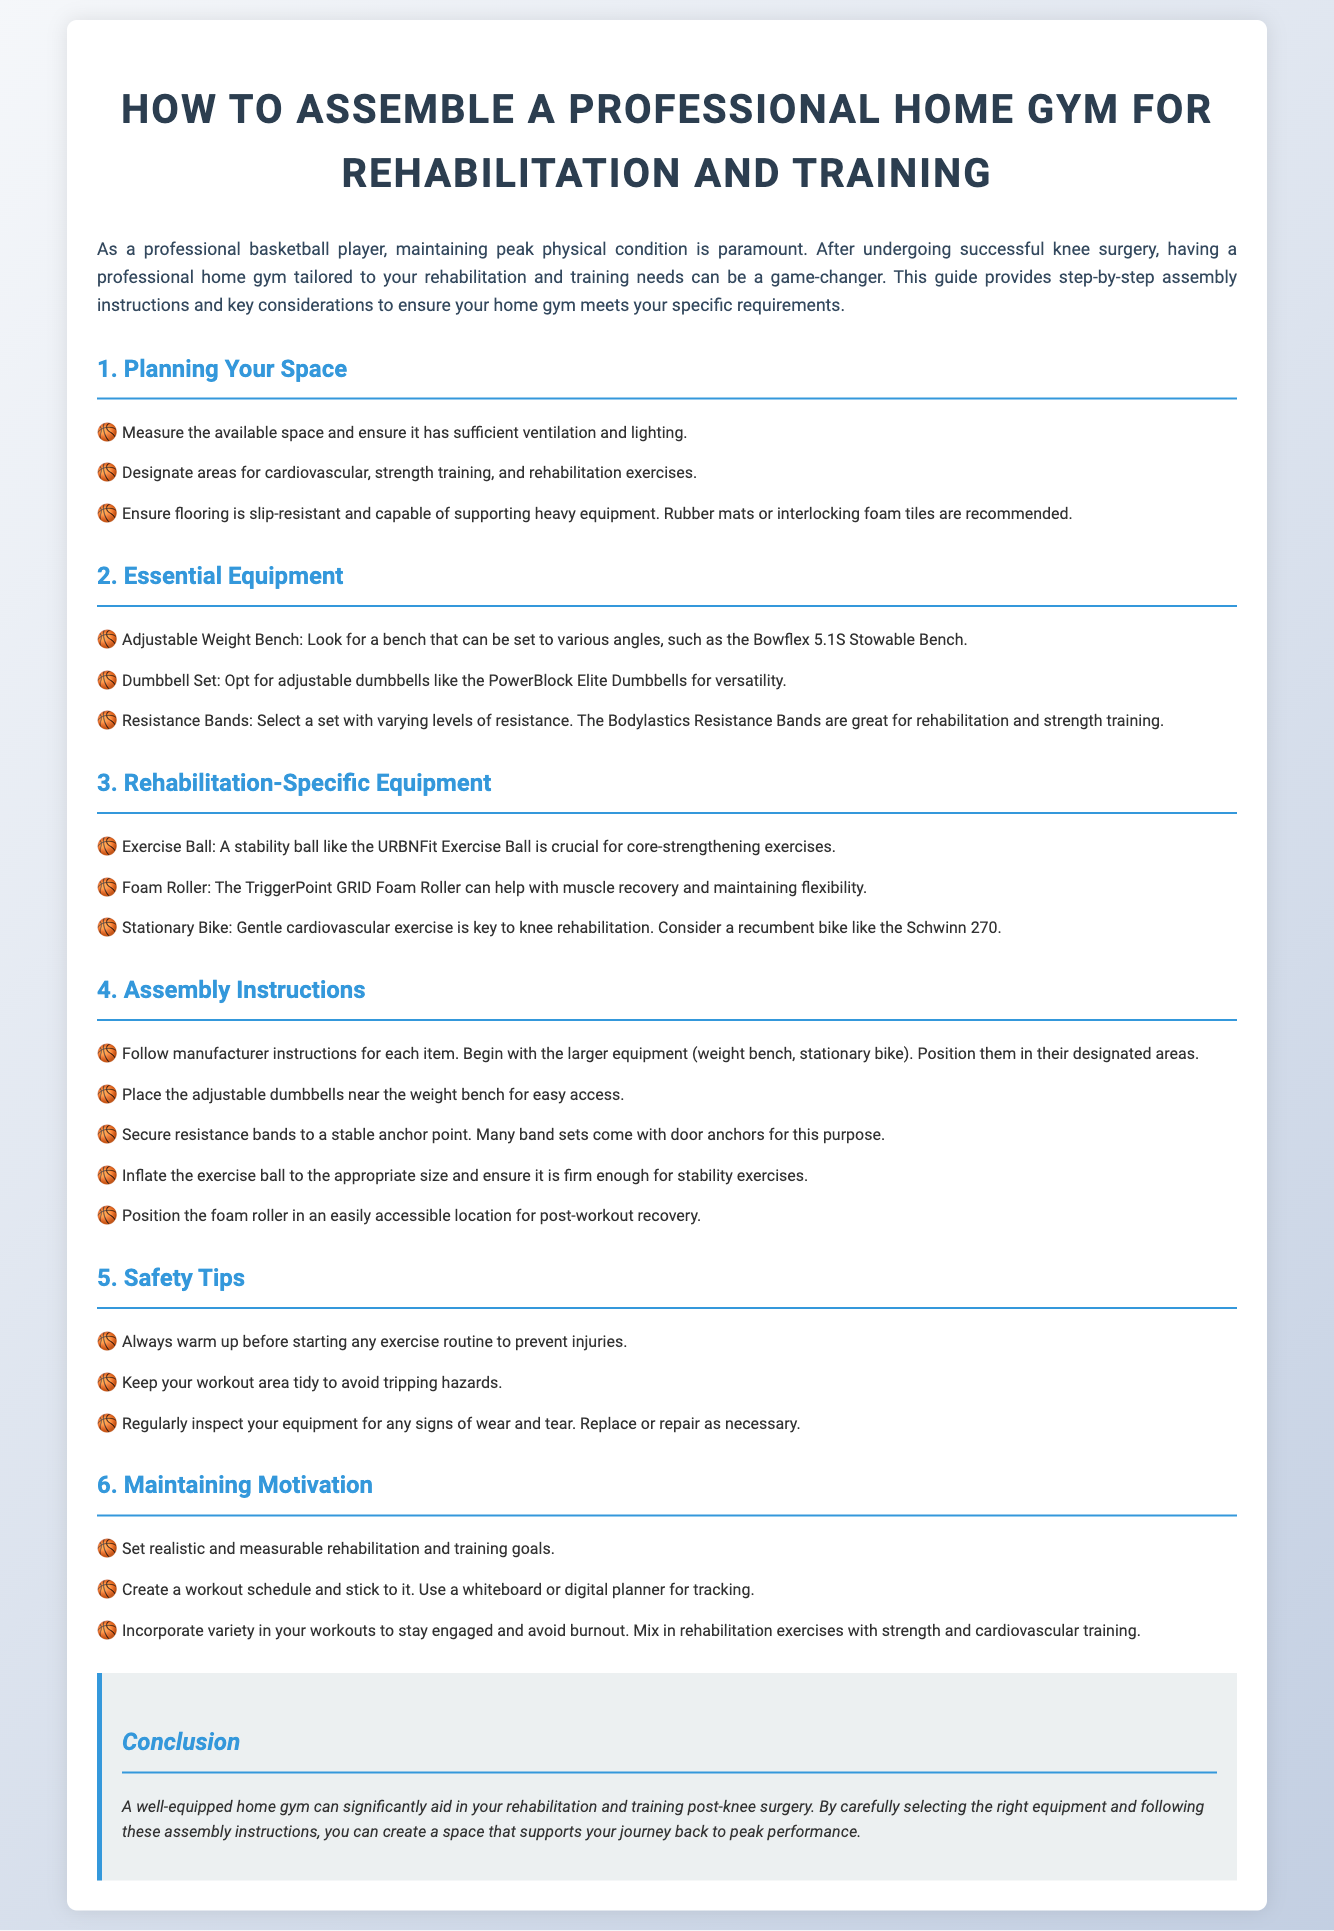what is the title of the document? The title of the document is found in the heading at the top of the page.
Answer: How to Assemble a Professional Home Gym for Rehabilitation and Training what type of flooring is recommended? The document suggests flooring that is slip-resistant and capable of supporting heavy equipment.
Answer: Rubber mats or interlocking foam tiles which adjustable weight bench is mentioned? The specific model of adjustable weight bench is identified in the Essential Equipment section.
Answer: Bowflex 5.1S Stowable Bench how many safety tips are provided? The number of safety tips is listed in the Safety Tips section.
Answer: Three what is a key piece of rehabilitation-specific equipment? This can be found in the Rehabilitation-Specific Equipment section.
Answer: Exercise Ball what brand of stationary bike is recommended? The recommended brand of stationary bike is mentioned in the Rehabilitation-Specific Equipment section.
Answer: Schwinn 270 which band set is suggested for resistance training? The document specifies a recommended brand for resistance bands.
Answer: Bodylastics Resistance Bands what should you do before starting any exercise routine? The document provides advice on preparation before workouts.
Answer: Warm up how can you maintain motivation according to the document? This question refers to the methods mentioned in the Maintaining Motivation section.
Answer: Set realistic and measurable rehabilitation and training goals 